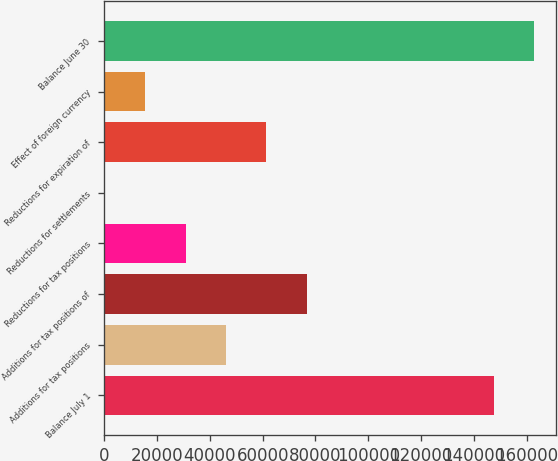Convert chart to OTSL. <chart><loc_0><loc_0><loc_500><loc_500><bar_chart><fcel>Balance July 1<fcel>Additions for tax positions<fcel>Additions for tax positions of<fcel>Reductions for tax positions<fcel>Reductions for settlements<fcel>Reductions for expiration of<fcel>Effect of foreign currency<fcel>Balance June 30<nl><fcel>147506<fcel>46147.8<fcel>76703<fcel>30870.2<fcel>315<fcel>61425.4<fcel>15592.6<fcel>162784<nl></chart> 